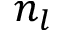<formula> <loc_0><loc_0><loc_500><loc_500>n _ { l }</formula> 